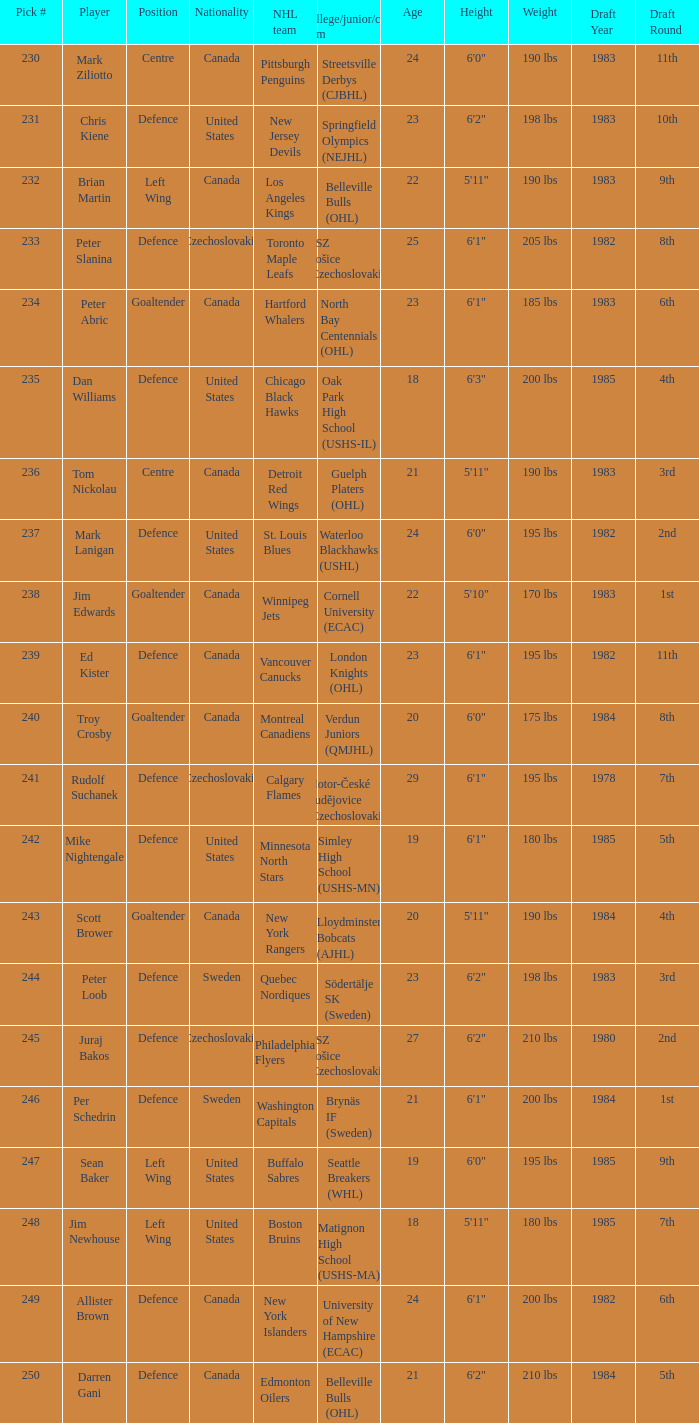Which draft number did the new jersey devils get? 231.0. 